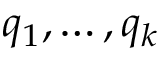Convert formula to latex. <formula><loc_0><loc_0><loc_500><loc_500>q _ { 1 } , \dots , q _ { k }</formula> 